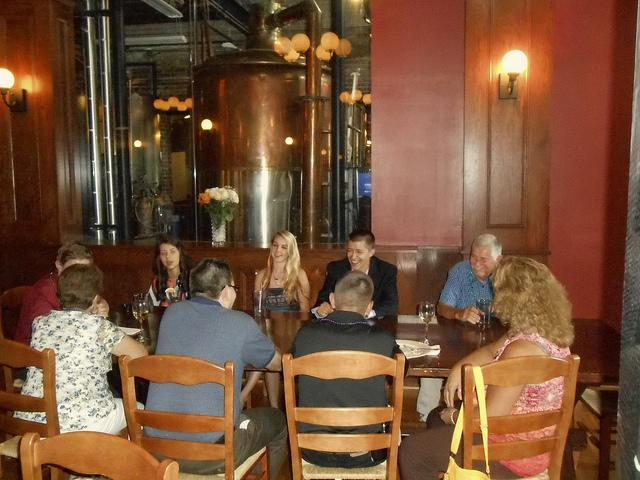What is the equipment in the background used for? Please explain your reasoning. brewing. It's to brew assorted types of beer. 